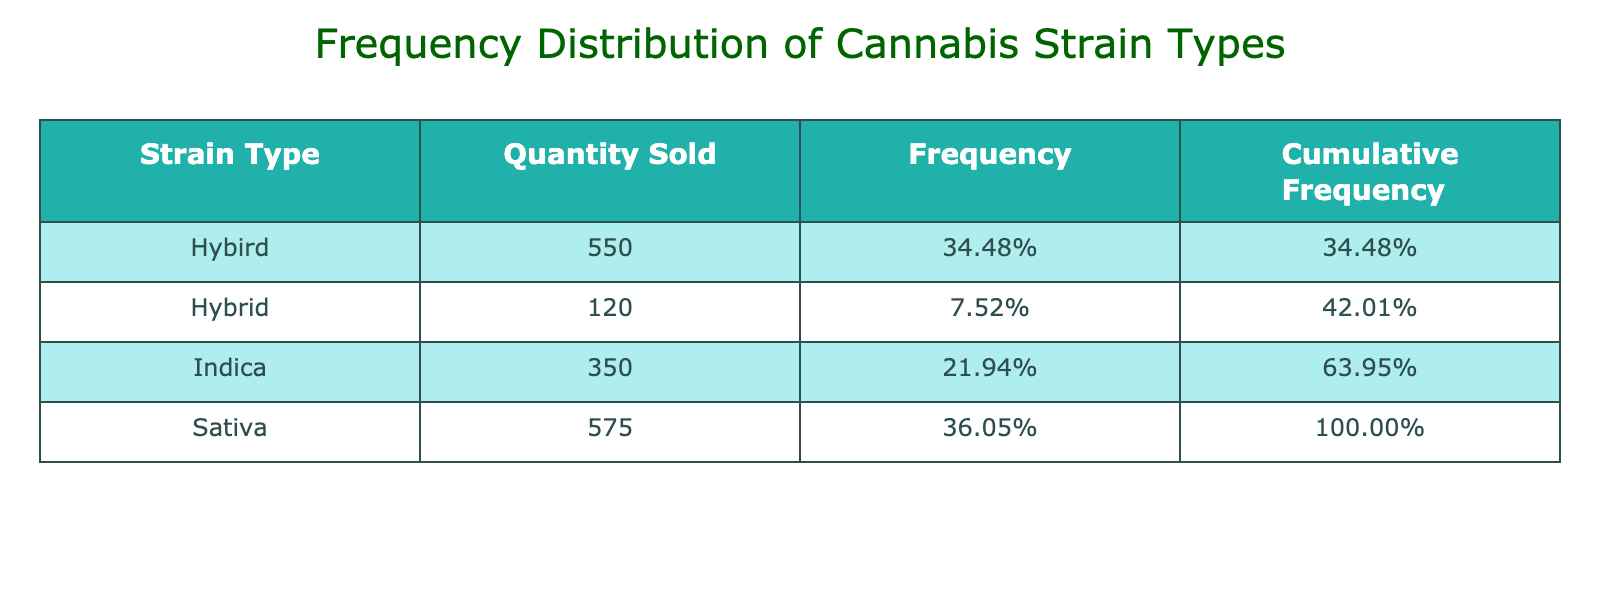What strain type had the highest quantity sold? By reviewing the "Quantity Sold" column in the table, we can see that "Gelato" under the "Hybrid" strain type had the highest value of 160.
Answer: Hybrid What is the total quantity sold for Indica strain types? Looking at the "Indica" category, we sum the quantities: 80 (OG Kush) + 90 (Northern Lights) + 70 (Granddaddy Purple) + 60 (Lavender) + 50 (Bubba Kush) = 350.
Answer: 350 Did any Sativa strain type have a lower quantity sold than 100? Checking the "Sativa" strain types, we see that "Trainwreck" had a quantity of 95, which is lower than 100.
Answer: Yes What is the cumulative frequency percentage for the Sativa strain types? First, we check the total quantity sold for all Sativa strains: 100 (Sour Diesel) + 140 (Jack Herer) + 110 (Green Crack) + 130 (Lemon Haze) + 95 (Trainwreck) = 575. Next, we find the frequency by dividing 575 by the total quantity (1,200) which gives us approximately 47.92%.
Answer: Approximately 48% Which strain type accounts for more than 30% of the total sales? Examining the frequencies in the table, we see that "Hybrid" with a total frequency of 46.67% exceeds 30%. Conversely, the Sativa and Indica types do not exceed 30%, hence "Hybrid" is the only strain type that meets this criterion.
Answer: Hybrid What is the ratio of Hybrid strains sold compared to Indica strains sold? This requires us to calculate the total quantity sold for Hybrid (150 + 120 + 110 + 130 + 160 = 670) and Indica (350 from the previous calculation) and find the ratio: 670/350 simplifies to approximately 1.91.
Answer: Approximately 1.91 How many Sativa strains were sold in total? We count the number of entries under Sativa: there are 5 strains, which are "Sour Diesel," "Jack Herer," "Green Crack," "Lemon Haze," and "Trainwreck."
Answer: 5 Is the quantity of sold Hybrid strains greater than that of Sativa strains? First, we sum the quantities for each: "Hybrid" strains total 670 and "Sativa" strains total 575. Since 670 is greater than 575, we confirm that Hybrid strains had more sold.
Answer: Yes 